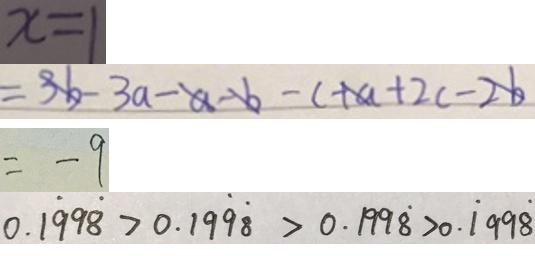Convert formula to latex. <formula><loc_0><loc_0><loc_500><loc_500>x = 1 
 = 3 b - 3 a - a - b - c + a + 2 c - 2 b 
 = - 9 
 0 . 1 \dot { 9 } 9 \dot { 8 } > 0 . 1 \dot { 9 } \dot { 8 } > 0 . 1 9 9 \dot { 8 } > 0 . \dot { 1 } 9 9 \dot { 8 }</formula> 